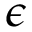<formula> <loc_0><loc_0><loc_500><loc_500>\epsilon</formula> 